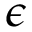<formula> <loc_0><loc_0><loc_500><loc_500>\epsilon</formula> 